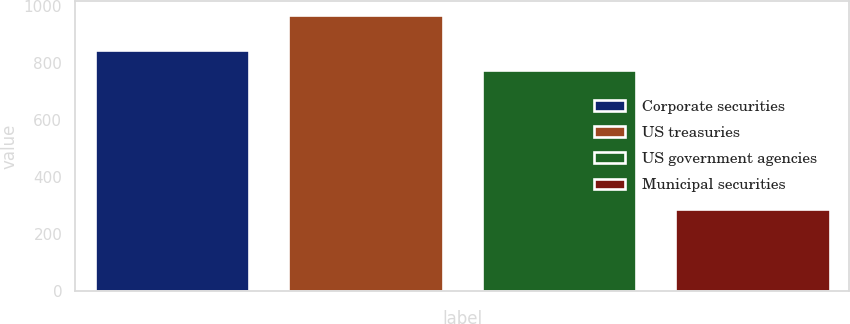Convert chart. <chart><loc_0><loc_0><loc_500><loc_500><bar_chart><fcel>Corporate securities<fcel>US treasuries<fcel>US government agencies<fcel>Municipal securities<nl><fcel>844.6<fcel>969.7<fcel>774.4<fcel>288<nl></chart> 